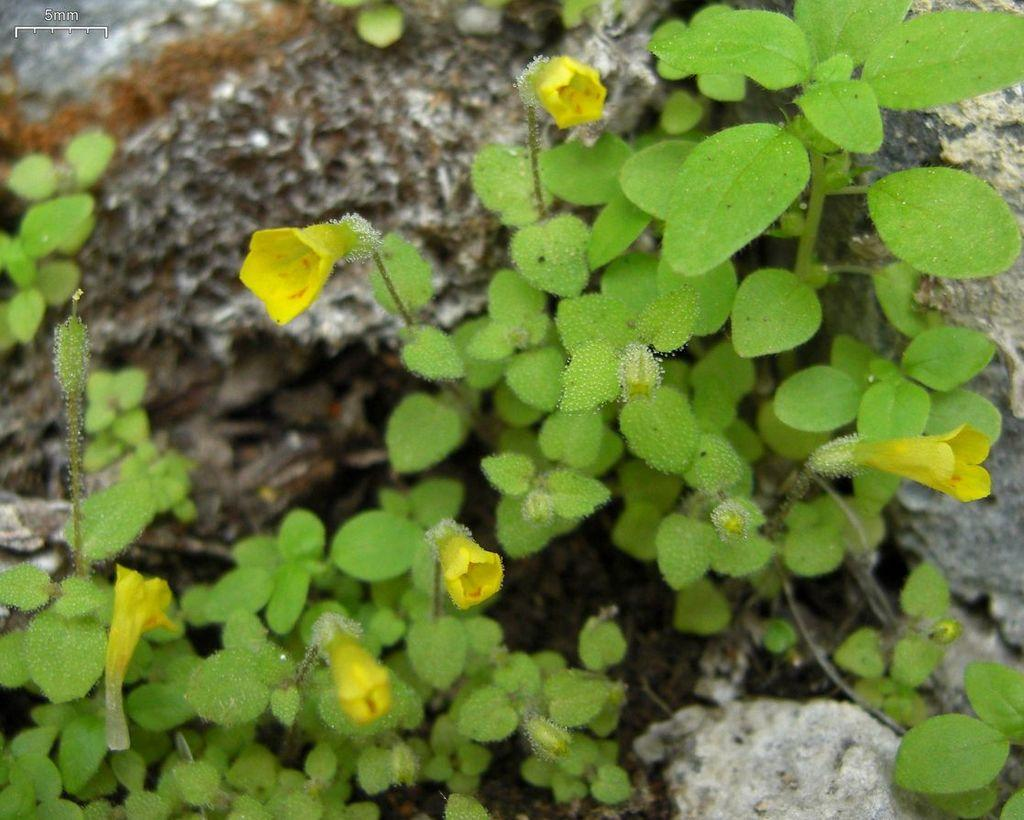What type of living organisms can be seen in the image? Plants and flowers are visible in the image. Can you describe the flowers in the image? The flowers in the image are part of the plants and add color and beauty to the scene. What type of machine is visible in the image? There is no machine present in the image; it features plants and flowers. Can you describe the lettuce in the image? There is no lettuce present in the image; it features plants and flowers, but not lettuce specifically. 